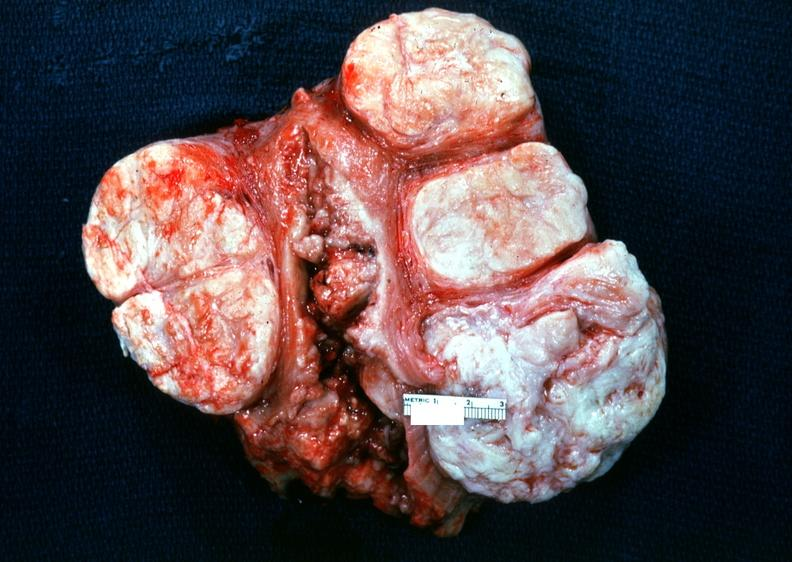does this image show uterus, leiomyoma?
Answer the question using a single word or phrase. Yes 